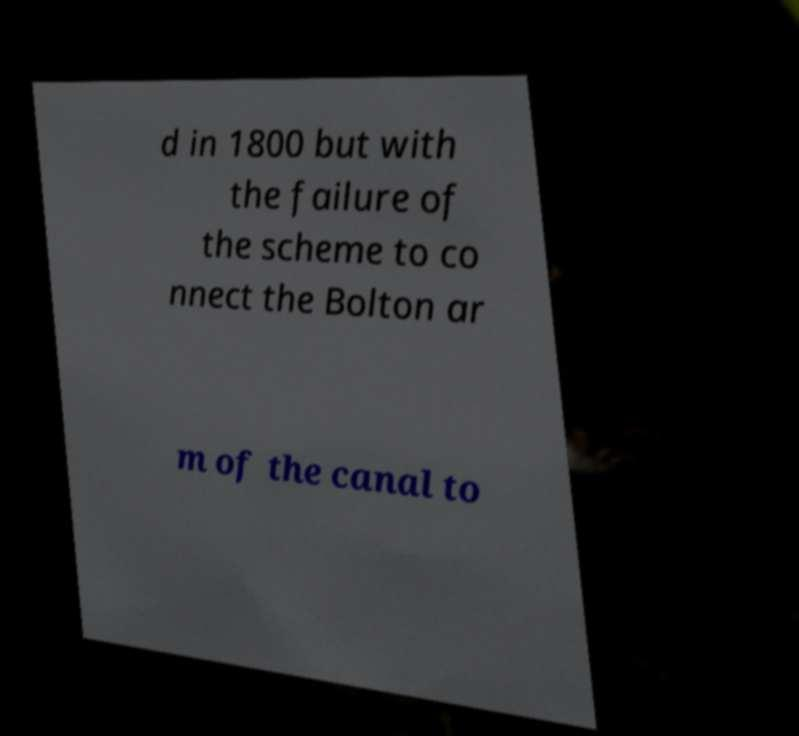For documentation purposes, I need the text within this image transcribed. Could you provide that? d in 1800 but with the failure of the scheme to co nnect the Bolton ar m of the canal to 